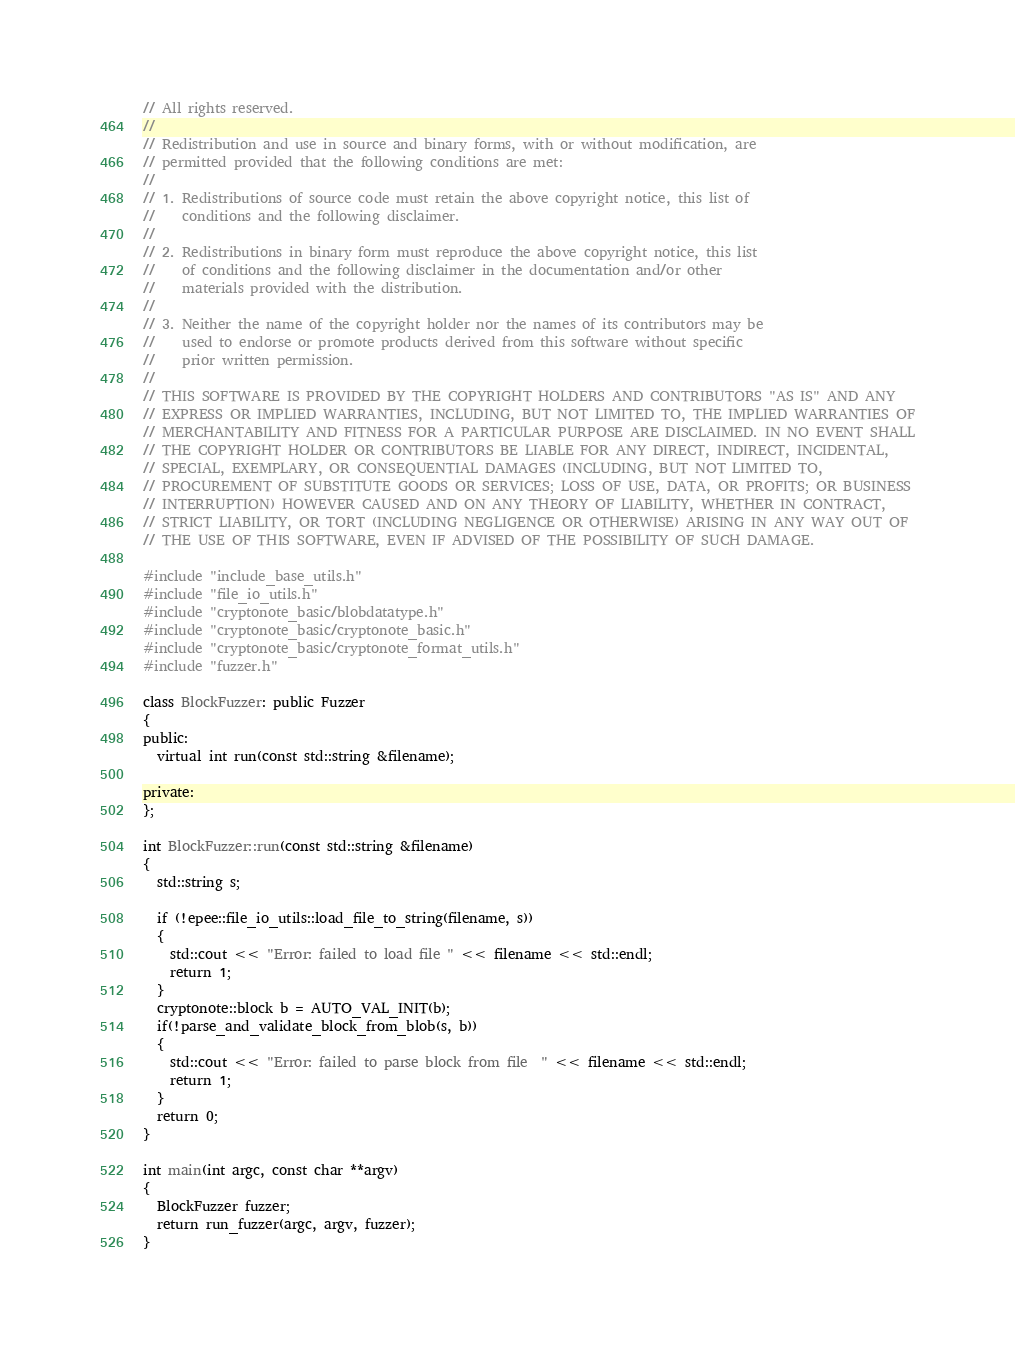<code> <loc_0><loc_0><loc_500><loc_500><_C++_>// All rights reserved.
// 
// Redistribution and use in source and binary forms, with or without modification, are
// permitted provided that the following conditions are met:
// 
// 1. Redistributions of source code must retain the above copyright notice, this list of
//    conditions and the following disclaimer.
// 
// 2. Redistributions in binary form must reproduce the above copyright notice, this list
//    of conditions and the following disclaimer in the documentation and/or other
//    materials provided with the distribution.
// 
// 3. Neither the name of the copyright holder nor the names of its contributors may be
//    used to endorse or promote products derived from this software without specific
//    prior written permission.
// 
// THIS SOFTWARE IS PROVIDED BY THE COPYRIGHT HOLDERS AND CONTRIBUTORS "AS IS" AND ANY
// EXPRESS OR IMPLIED WARRANTIES, INCLUDING, BUT NOT LIMITED TO, THE IMPLIED WARRANTIES OF
// MERCHANTABILITY AND FITNESS FOR A PARTICULAR PURPOSE ARE DISCLAIMED. IN NO EVENT SHALL
// THE COPYRIGHT HOLDER OR CONTRIBUTORS BE LIABLE FOR ANY DIRECT, INDIRECT, INCIDENTAL,
// SPECIAL, EXEMPLARY, OR CONSEQUENTIAL DAMAGES (INCLUDING, BUT NOT LIMITED TO,
// PROCUREMENT OF SUBSTITUTE GOODS OR SERVICES; LOSS OF USE, DATA, OR PROFITS; OR BUSINESS
// INTERRUPTION) HOWEVER CAUSED AND ON ANY THEORY OF LIABILITY, WHETHER IN CONTRACT,
// STRICT LIABILITY, OR TORT (INCLUDING NEGLIGENCE OR OTHERWISE) ARISING IN ANY WAY OUT OF
// THE USE OF THIS SOFTWARE, EVEN IF ADVISED OF THE POSSIBILITY OF SUCH DAMAGE.

#include "include_base_utils.h"
#include "file_io_utils.h"
#include "cryptonote_basic/blobdatatype.h"
#include "cryptonote_basic/cryptonote_basic.h"
#include "cryptonote_basic/cryptonote_format_utils.h"
#include "fuzzer.h"

class BlockFuzzer: public Fuzzer
{
public:
  virtual int run(const std::string &filename);

private:
};

int BlockFuzzer::run(const std::string &filename)
{
  std::string s;

  if (!epee::file_io_utils::load_file_to_string(filename, s))
  {
    std::cout << "Error: failed to load file " << filename << std::endl;
    return 1;
  }
  cryptonote::block b = AUTO_VAL_INIT(b);
  if(!parse_and_validate_block_from_blob(s, b))
  {
    std::cout << "Error: failed to parse block from file  " << filename << std::endl;
    return 1;
  }
  return 0;
}

int main(int argc, const char **argv)
{
  BlockFuzzer fuzzer;
  return run_fuzzer(argc, argv, fuzzer);
}
</code> 